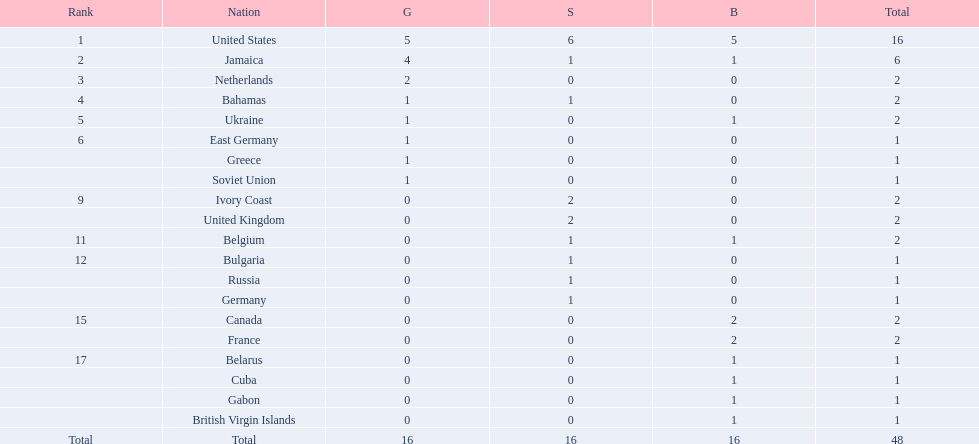What country won the most medals? United States. How many medals did the us win? 16. What is the most medals (after 16) that were won by a country? 6. Which country won 6 medals? Jamaica. 